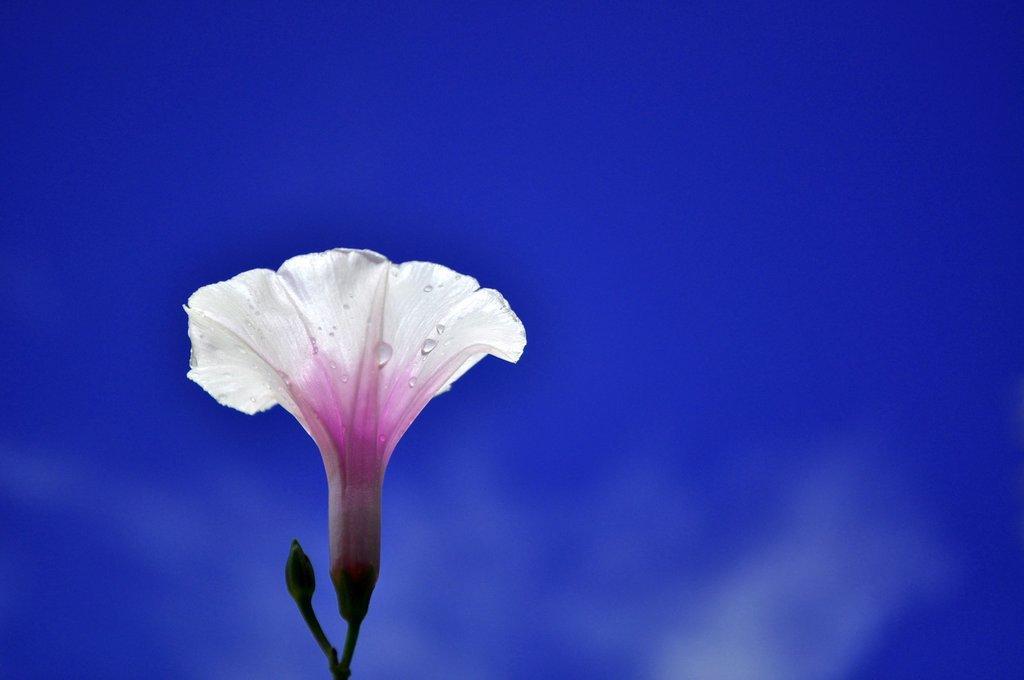In one or two sentences, can you explain what this image depicts? In this image I can see the flower and the bud. I can see the flower is in white and pink color. I can see the blue color background. 